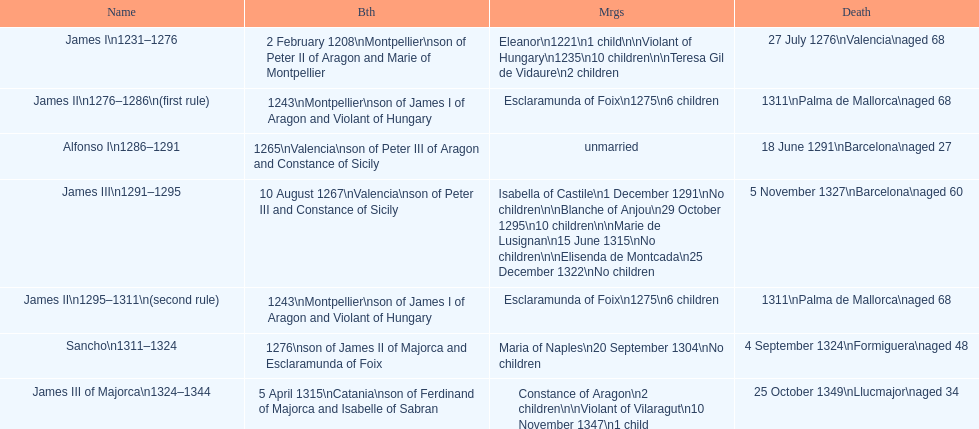How many total marriages did james i have? 3. 